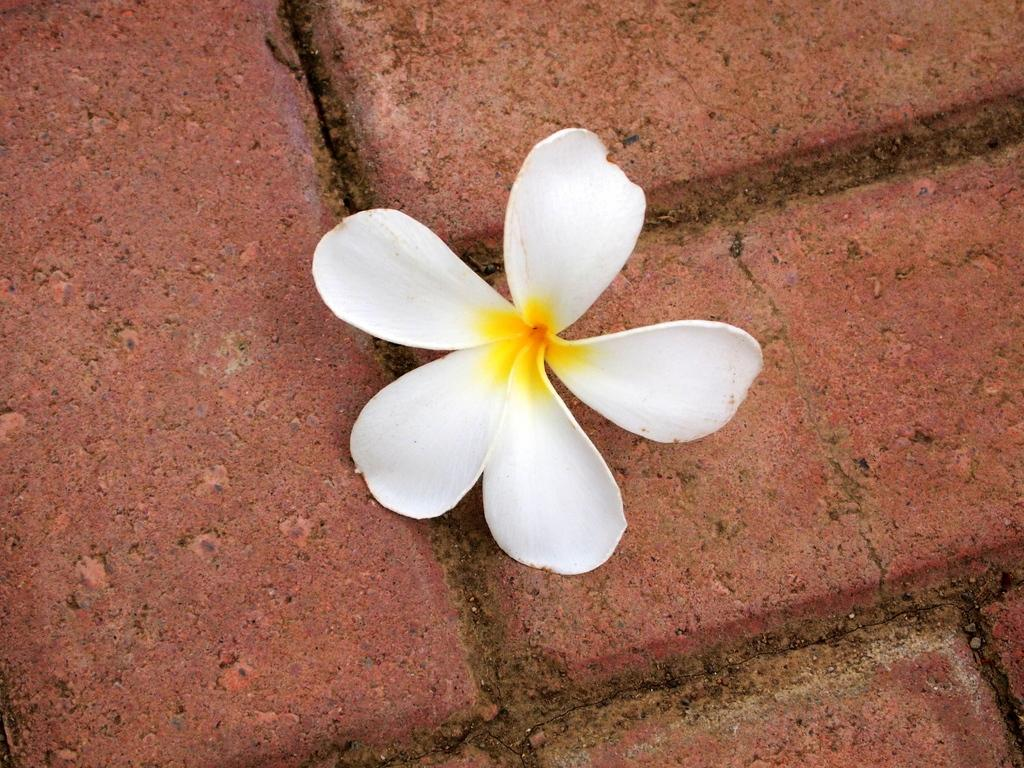What type of flower is in the image? There is a white flower in the image. Where is the flower located in the image? The flower is on the floor. What type of fairies can be seen interacting with the flower in the image? There are no fairies present in the image; it only features a white flower on the floor. 